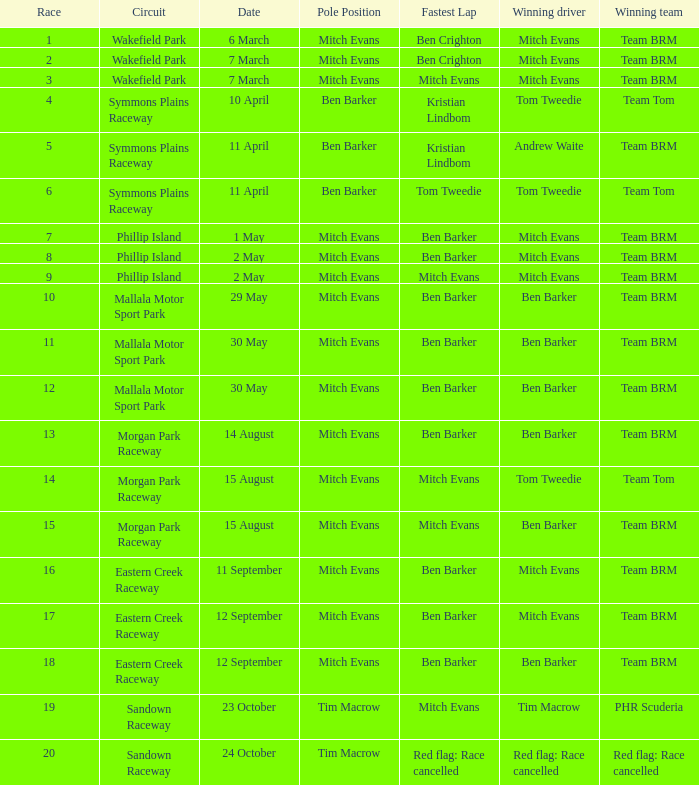In how many rounds was Race 17? 1.0. 